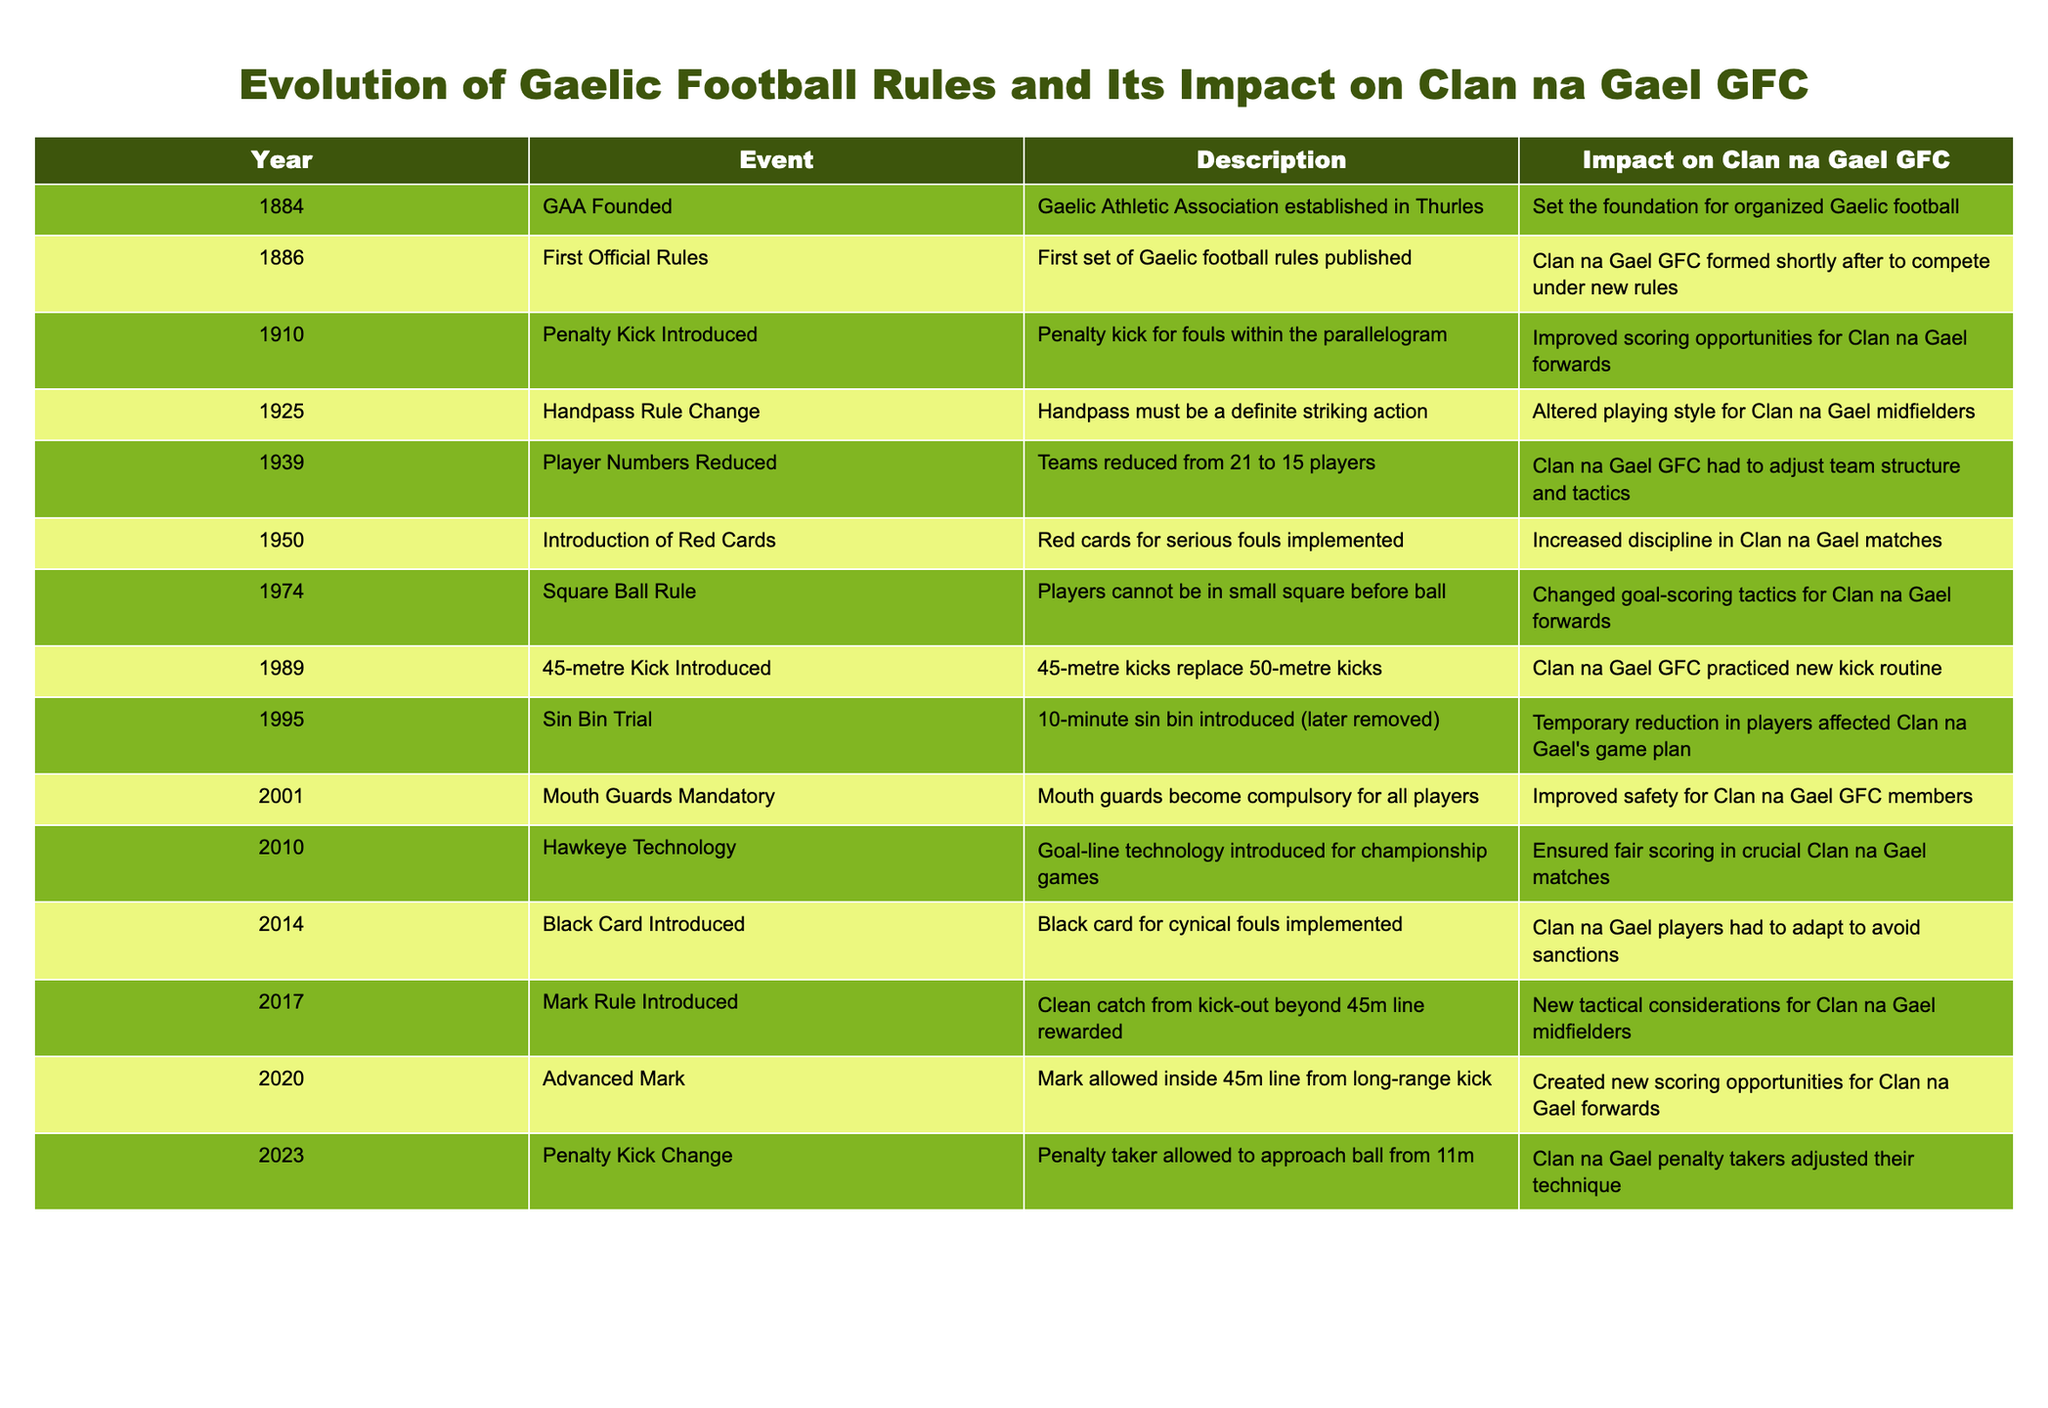What year was the GAA founded? The table indicates in the first row that the GAA was founded in 1884.
Answer: 1884 How many players were there on a team before the 1939 rule change? The table states that prior to the 1939 change, each team had 21 players.
Answer: 21 players What event in 2014 introduced a new type of foul penalty? The Black Card was introduced in 2014 for cynical fouls according to the table.
Answer: Black Card introduction Which rule change occurred in 2001, and what was its purpose? The table mentions that mouth guards became mandatory in 2001 to improve safety for players.
Answer: Mouth guards mandatory for safety How many significant rule changes in Gaelic football affect scoring opportunities? Reviewing the table highlights four key events related to scoring: the introduction of the penalty kick in 1910, Square Ball Rule in 1974, the 45-metre kick change in 1989, and the Advanced Mark in 2020, making a total of four changes.
Answer: Four rule changes Did the introduction of the sin bin in 1995 remain a permanent rule? According to the table, the sin bin was a trial and later removed, confirming it was not a permanent rule.
Answer: No What impact did the 1939 player number reduction have on Clan na Gael GFC? The table states that the reduction from 21 to 15 players forced Clan na Gael GFC to adjust their team structure and tactics.
Answer: Adjusted team structure How did the introduction of Hawkeye technology in 2010 benefit Clan na Gael GFC? The table notes that the introduction of Hawkeye technology ensured fair scoring in crucial matches, benefiting their performance.
Answer: Ensured fair scoring What was the difference in penalty kick regulations before and after 2023? The table indicates that prior to 2023, there were no specific rules regarding the penalty taker's approach, while the 2023 rule allows the taker to approach the ball from 11m. Therefore, the recent change clarified the approach distance for penalty takers.
Answer: Penalty taker can approach from 11m now 